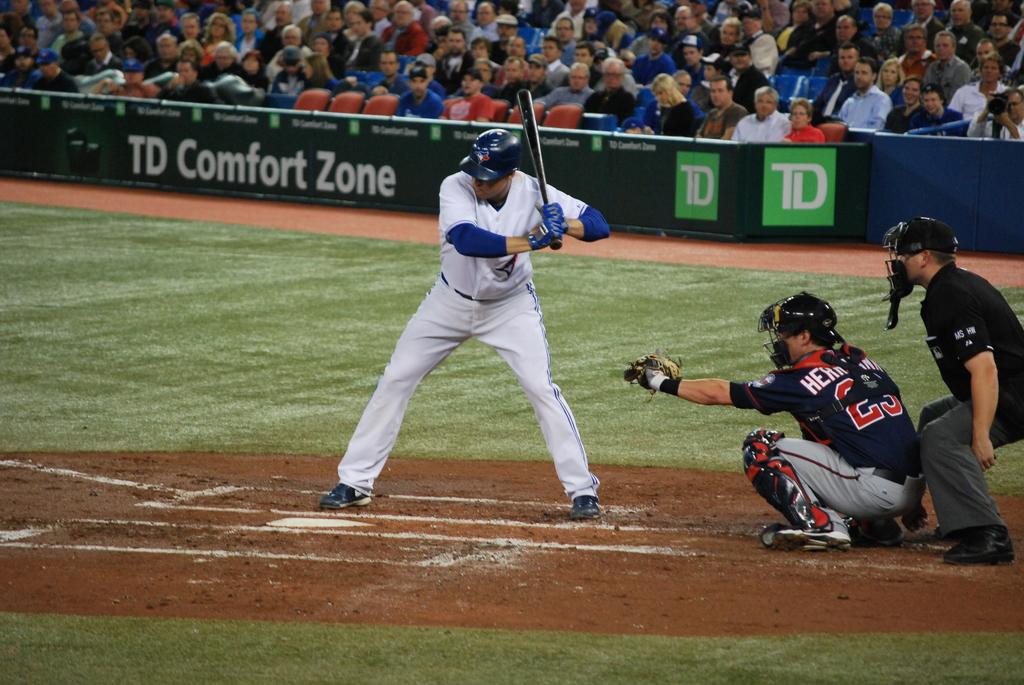What kind of zone is behind the hitter?
Provide a short and direct response. Td comfort zone. What does the green board say in the back where the crowd is?
Your response must be concise. Td comfort zone. 